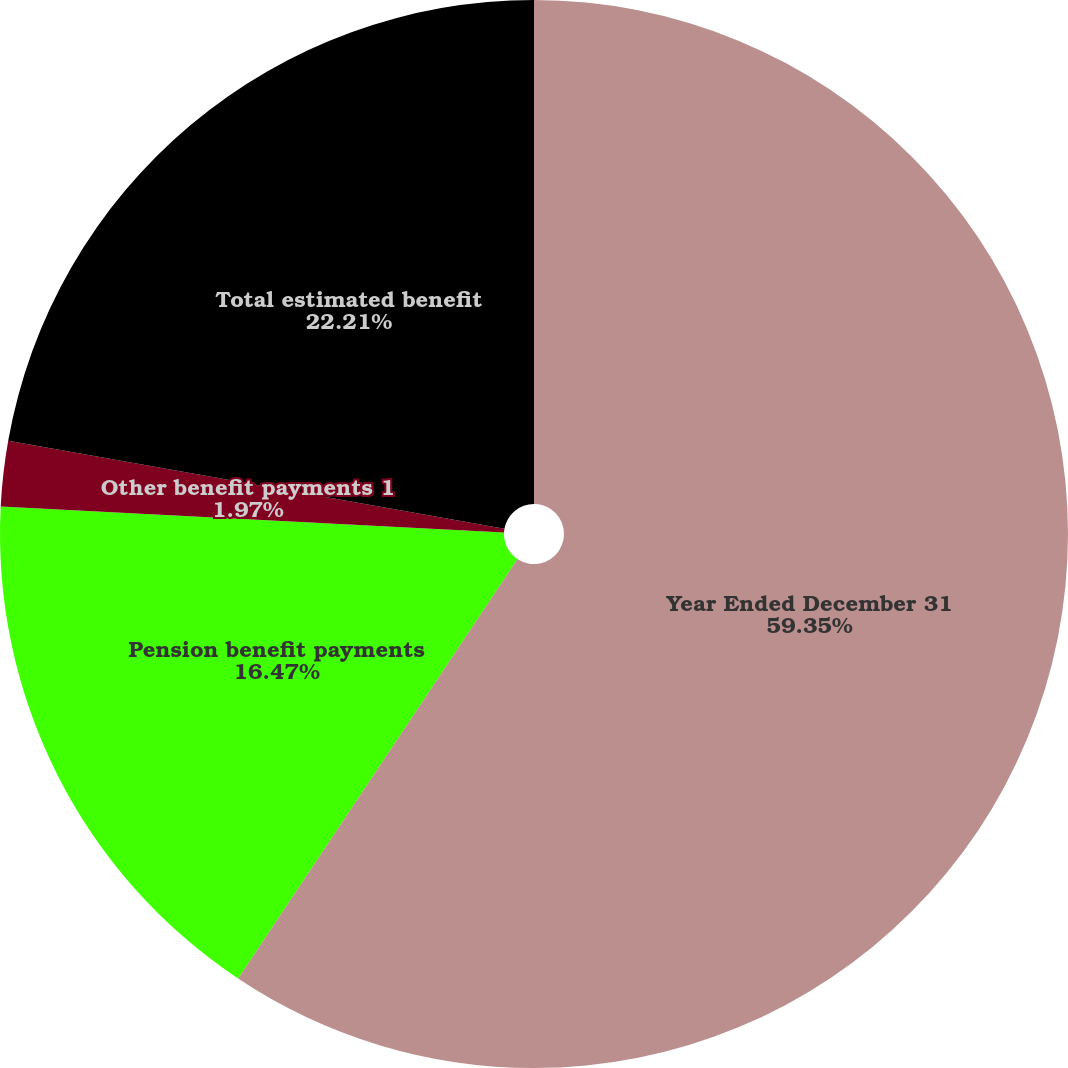<chart> <loc_0><loc_0><loc_500><loc_500><pie_chart><fcel>Year Ended December 31<fcel>Pension benefit payments<fcel>Other benefit payments 1<fcel>Total estimated benefit<nl><fcel>59.35%<fcel>16.47%<fcel>1.97%<fcel>22.21%<nl></chart> 